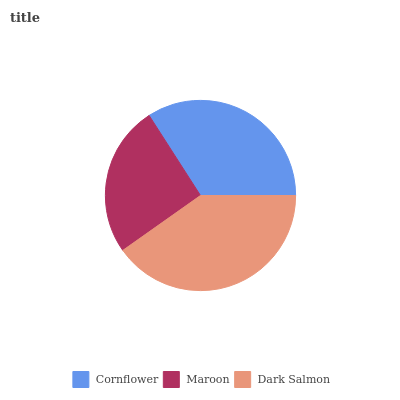Is Maroon the minimum?
Answer yes or no. Yes. Is Dark Salmon the maximum?
Answer yes or no. Yes. Is Dark Salmon the minimum?
Answer yes or no. No. Is Maroon the maximum?
Answer yes or no. No. Is Dark Salmon greater than Maroon?
Answer yes or no. Yes. Is Maroon less than Dark Salmon?
Answer yes or no. Yes. Is Maroon greater than Dark Salmon?
Answer yes or no. No. Is Dark Salmon less than Maroon?
Answer yes or no. No. Is Cornflower the high median?
Answer yes or no. Yes. Is Cornflower the low median?
Answer yes or no. Yes. Is Dark Salmon the high median?
Answer yes or no. No. Is Maroon the low median?
Answer yes or no. No. 